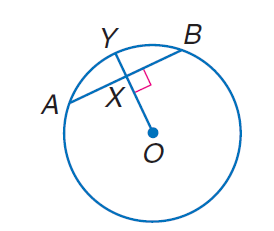Answer the mathemtical geometry problem and directly provide the correct option letter.
Question: Circle O has a radius of 10, A B = 10 and m \overrightarrow A B = 60. Find m \widehat O X.
Choices: A: 5 B: 5 \sqrt { 3 } C: 10 D: 15 B 